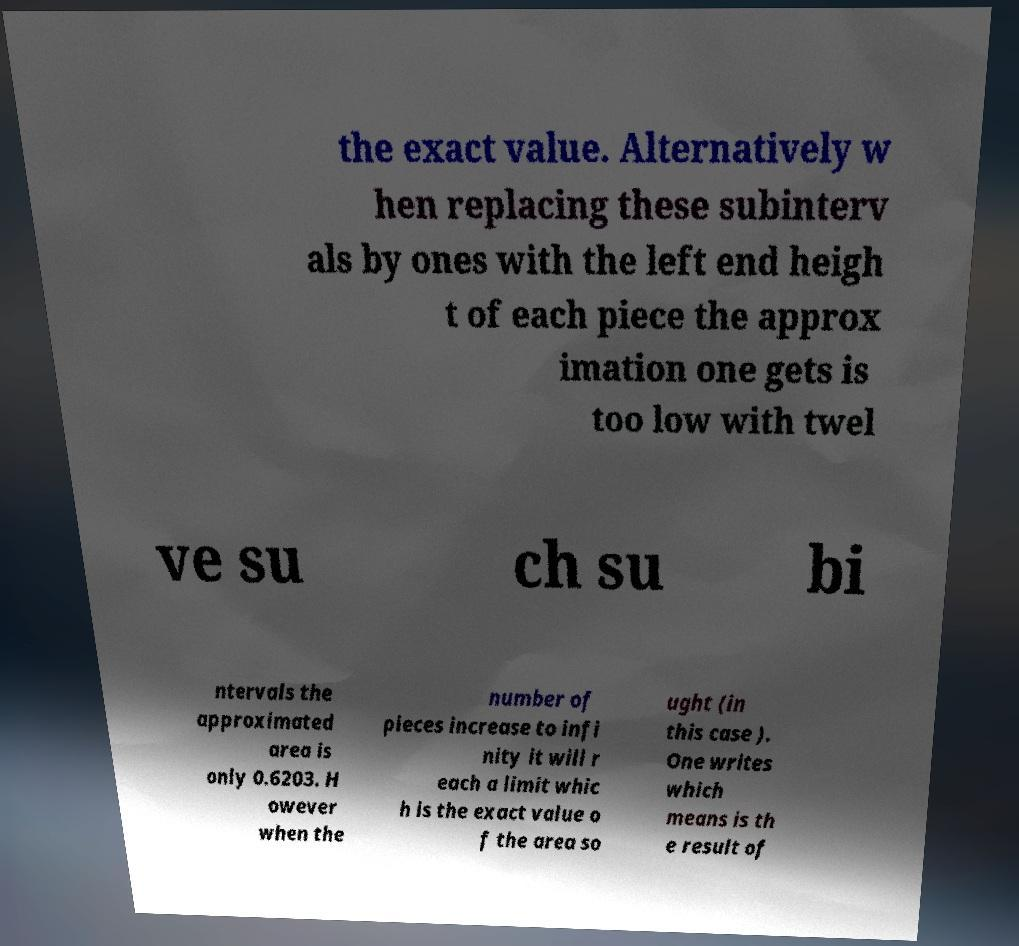Could you assist in decoding the text presented in this image and type it out clearly? the exact value. Alternatively w hen replacing these subinterv als by ones with the left end heigh t of each piece the approx imation one gets is too low with twel ve su ch su bi ntervals the approximated area is only 0.6203. H owever when the number of pieces increase to infi nity it will r each a limit whic h is the exact value o f the area so ught (in this case ). One writes which means is th e result of 